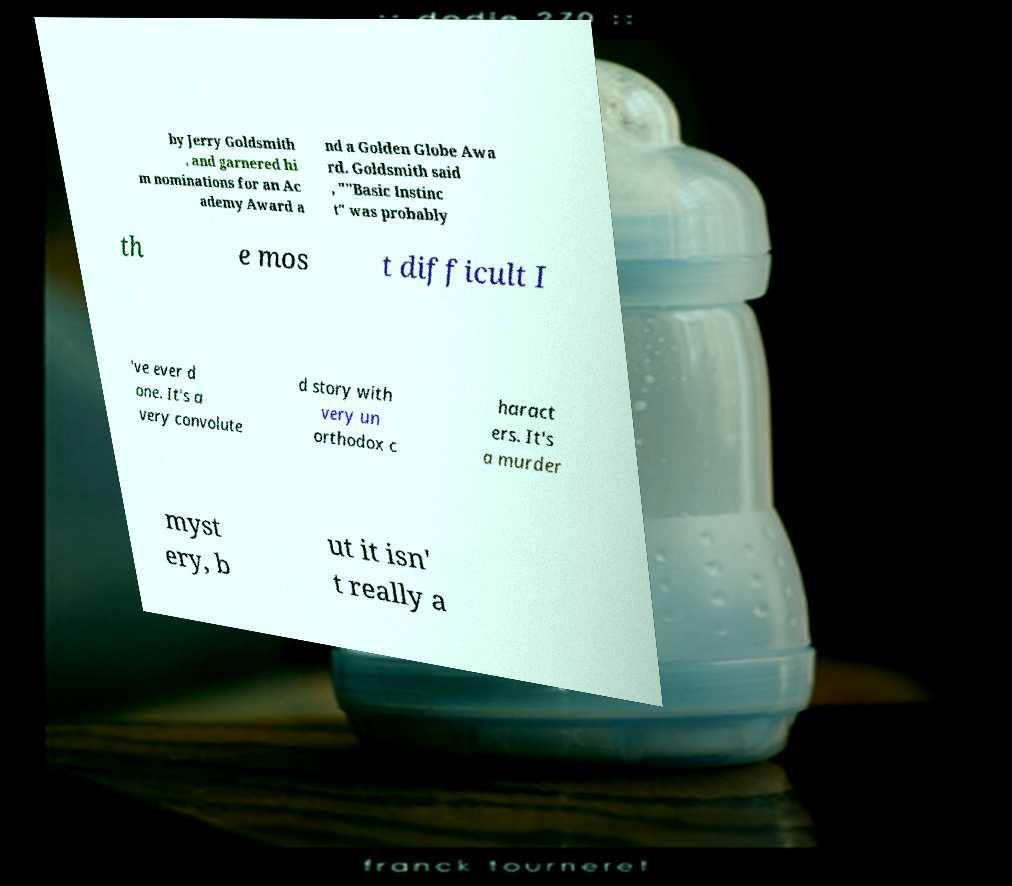Please read and relay the text visible in this image. What does it say? by Jerry Goldsmith , and garnered hi m nominations for an Ac ademy Award a nd a Golden Globe Awa rd. Goldsmith said , ""Basic Instinc t" was probably th e mos t difficult I 've ever d one. It's a very convolute d story with very un orthodox c haract ers. It's a murder myst ery, b ut it isn' t really a 